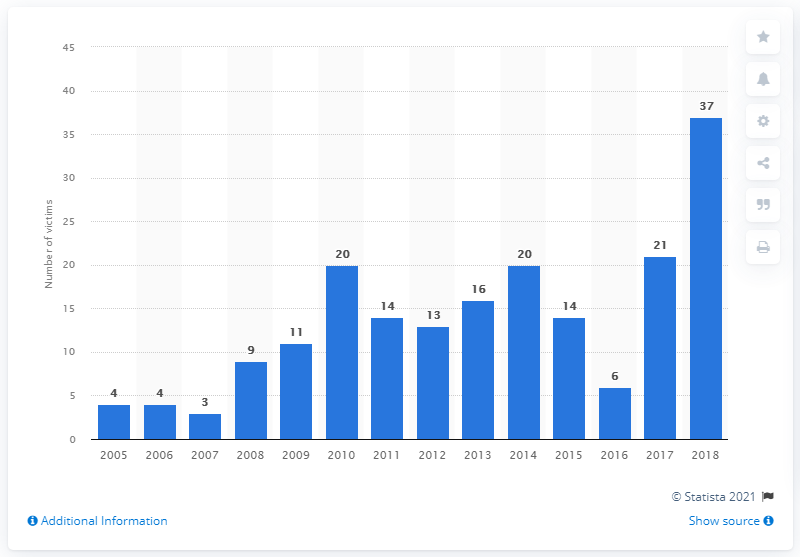What trends can be observed in the number of victims over the years shown in the graph? The graph shows a fluctuating trend in the number of victims over the years. After a low in early years, there's a noticeable increase in incidents, peaking in 2018. This suggests periods of heightened violence which could be due to various socio-political factors. 